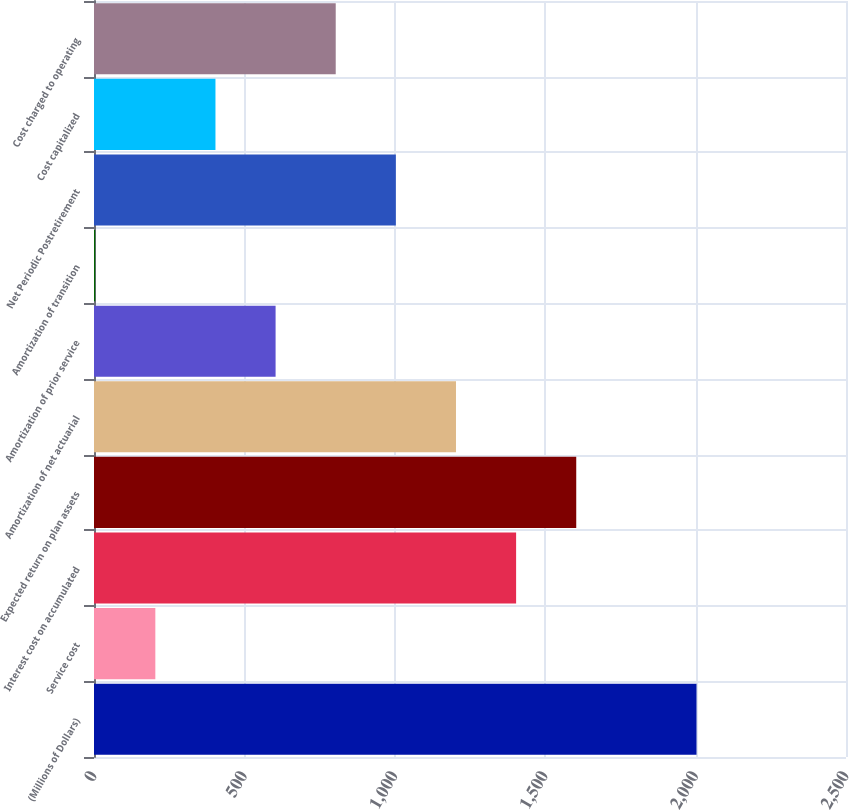Convert chart. <chart><loc_0><loc_0><loc_500><loc_500><bar_chart><fcel>(Millions of Dollars)<fcel>Service cost<fcel>Interest cost on accumulated<fcel>Expected return on plan assets<fcel>Amortization of net actuarial<fcel>Amortization of prior service<fcel>Amortization of transition<fcel>Net Periodic Postretirement<fcel>Cost capitalized<fcel>Cost charged to operating<nl><fcel>2003<fcel>203.9<fcel>1403.3<fcel>1603.2<fcel>1203.4<fcel>603.7<fcel>4<fcel>1003.5<fcel>403.8<fcel>803.6<nl></chart> 